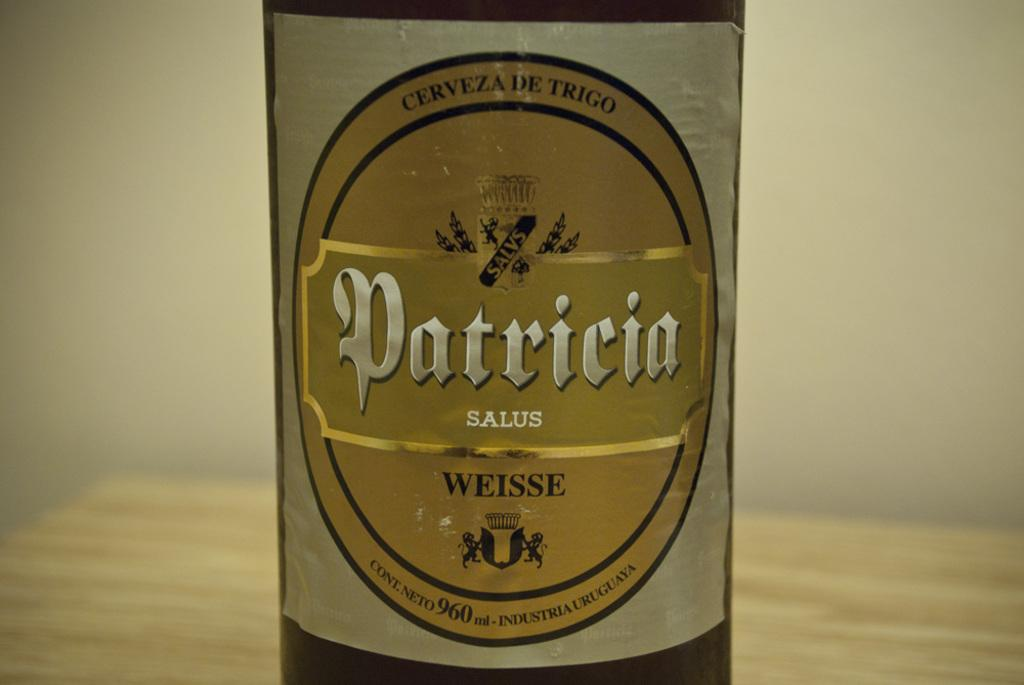<image>
Create a compact narrative representing the image presented. Bottle of alcohol with a label that says PATRICIA on it. 